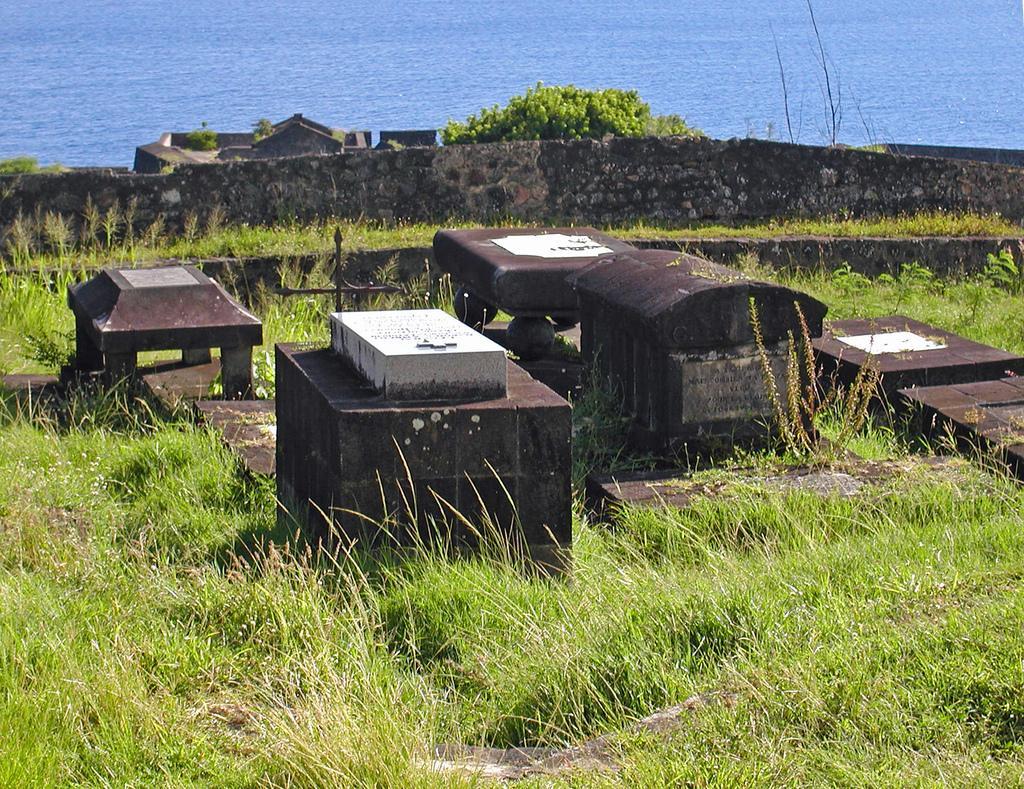How would you summarize this image in a sentence or two? In this image there is a grassland on that there are few metal objects, in the background there is a wall, trees and a sea. 